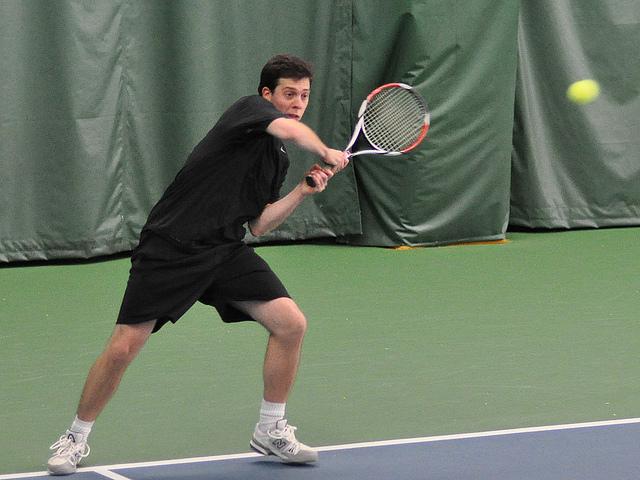What is the man about to do?
Give a very brief answer. Hit tennis ball. Is the man going to be able to hit the ball?
Keep it brief. Yes. What is the man holding?
Quick response, please. Tennis racket. What colors are the person's shoes?
Keep it brief. White. 